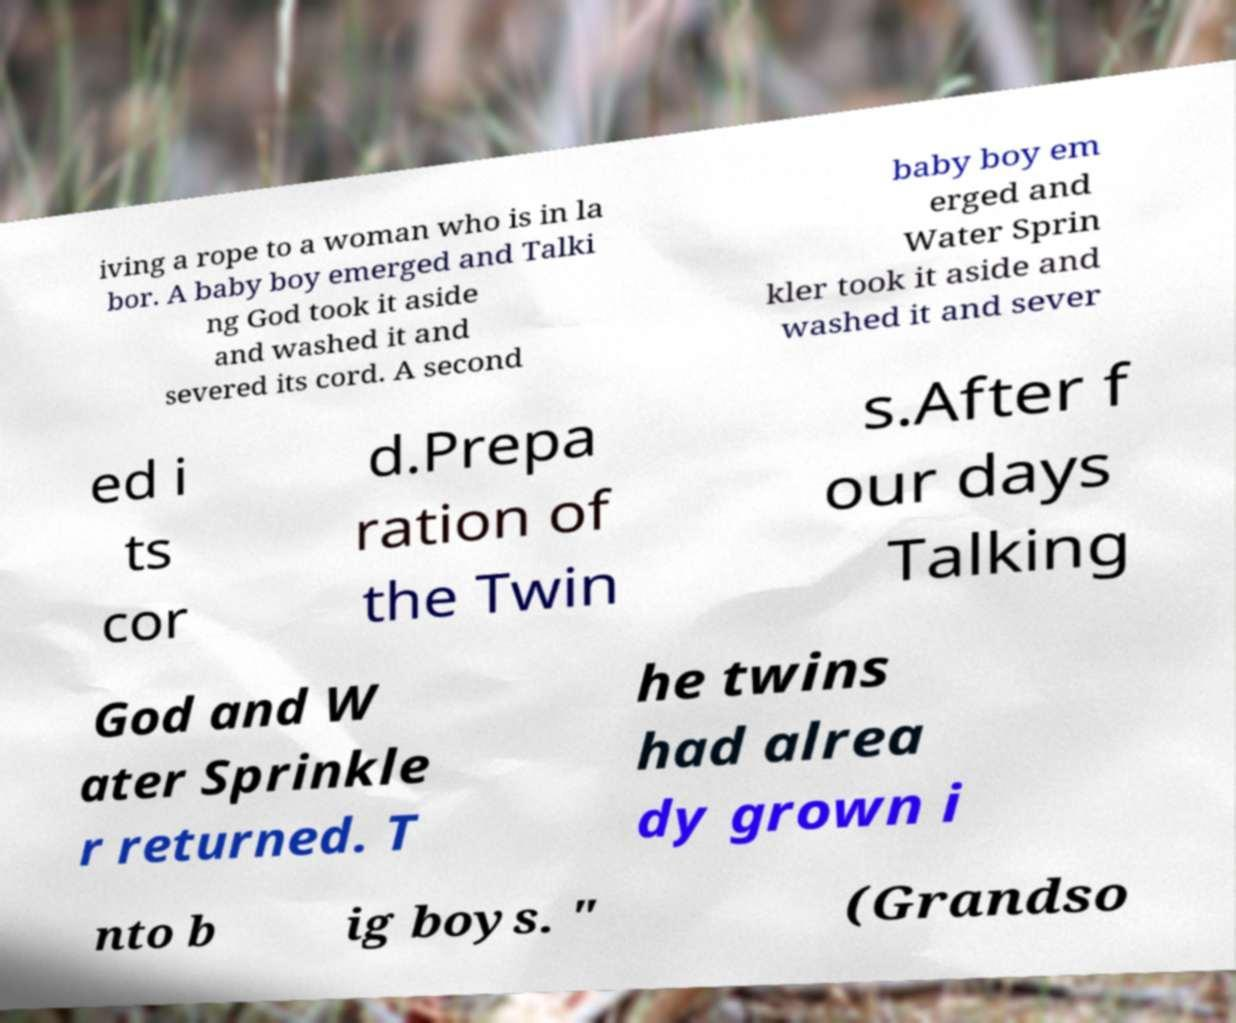What messages or text are displayed in this image? I need them in a readable, typed format. iving a rope to a woman who is in la bor. A baby boy emerged and Talki ng God took it aside and washed it and severed its cord. A second baby boy em erged and Water Sprin kler took it aside and washed it and sever ed i ts cor d.Prepa ration of the Twin s.After f our days Talking God and W ater Sprinkle r returned. T he twins had alrea dy grown i nto b ig boys. " (Grandso 